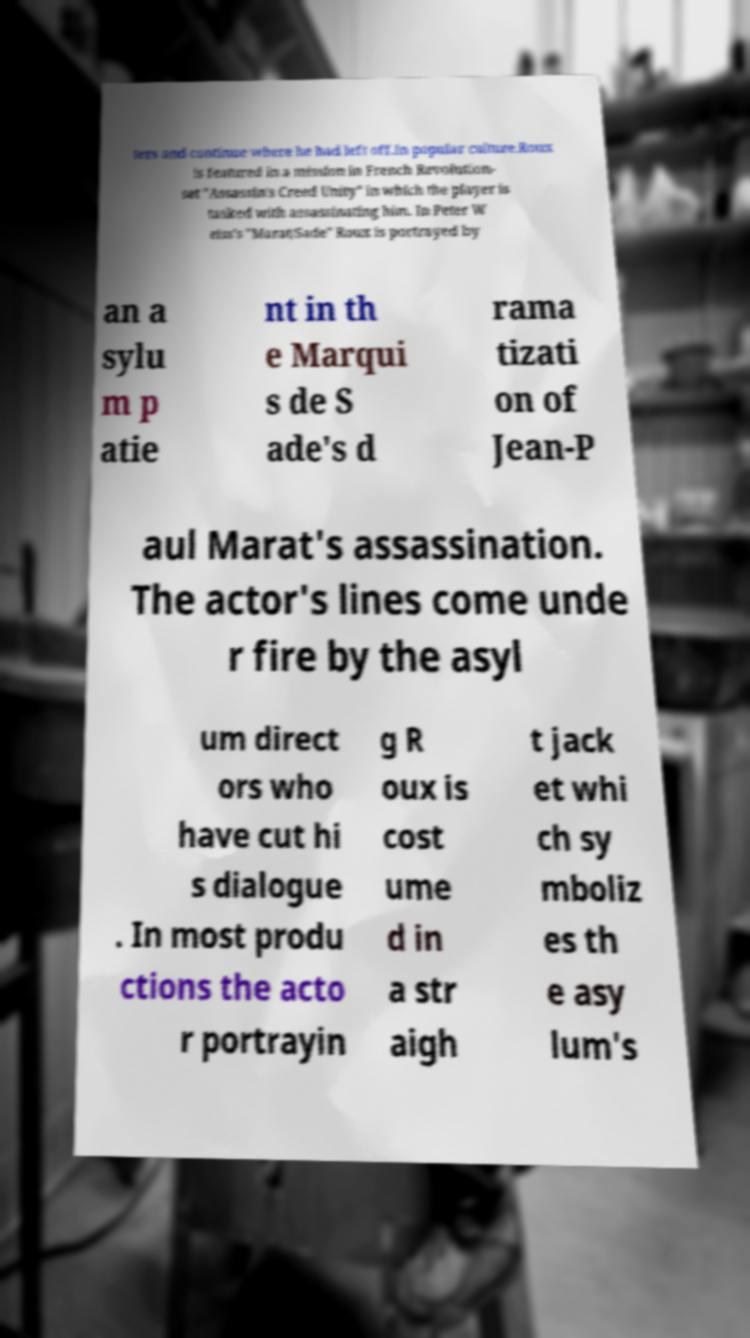Can you accurately transcribe the text from the provided image for me? ters and continue where he had left off.In popular culture.Roux is featured in a mission in French Revolution- set "Assassin's Creed Unity" in which the player is tasked with assassinating him. In Peter W eiss's "Marat/Sade" Roux is portrayed by an a sylu m p atie nt in th e Marqui s de S ade's d rama tizati on of Jean-P aul Marat's assassination. The actor's lines come unde r fire by the asyl um direct ors who have cut hi s dialogue . In most produ ctions the acto r portrayin g R oux is cost ume d in a str aigh t jack et whi ch sy mboliz es th e asy lum's 